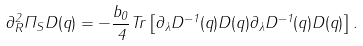<formula> <loc_0><loc_0><loc_500><loc_500>\partial _ { R } ^ { 2 } \Pi _ { S } D ( q ) = - \frac { b _ { 0 } } 4 T r \left [ \partial _ { \lambda } D ^ { - 1 } ( q ) D ( q ) \partial _ { \lambda } D ^ { - 1 } ( q ) D ( q ) \right ] .</formula> 